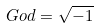<formula> <loc_0><loc_0><loc_500><loc_500>G o d = \sqrt { - 1 }</formula> 